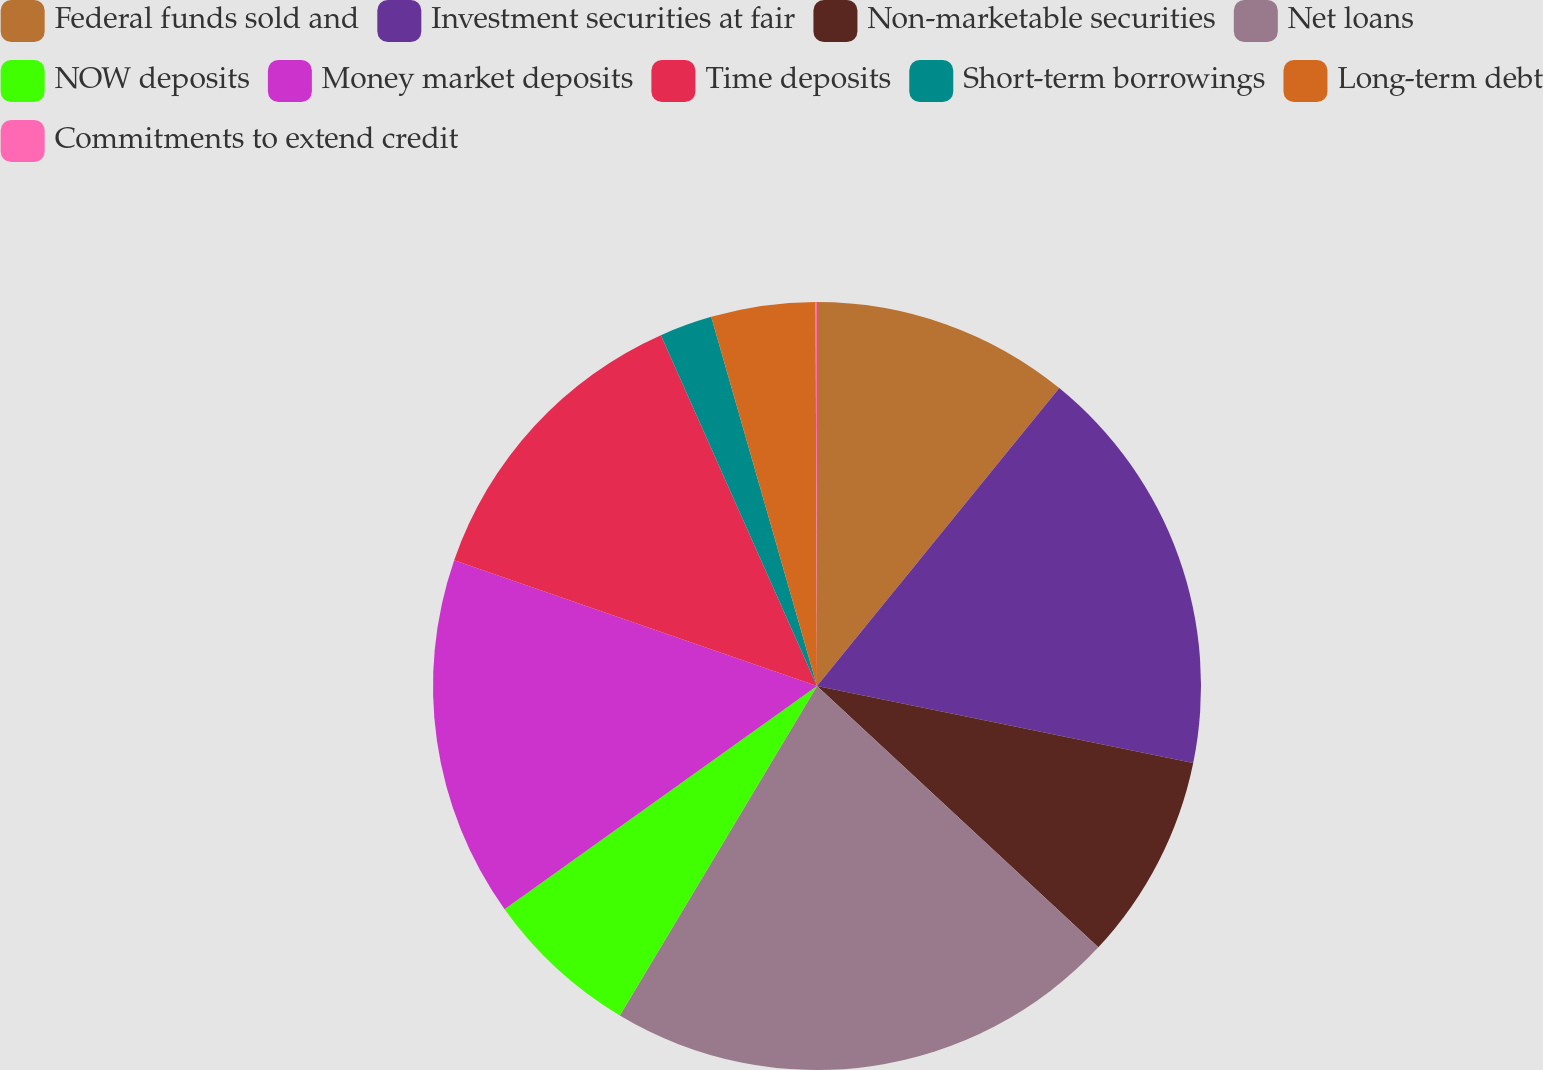<chart> <loc_0><loc_0><loc_500><loc_500><pie_chart><fcel>Federal funds sold and<fcel>Investment securities at fair<fcel>Non-marketable securities<fcel>Net loans<fcel>NOW deposits<fcel>Money market deposits<fcel>Time deposits<fcel>Short-term borrowings<fcel>Long-term debt<fcel>Commitments to extend credit<nl><fcel>10.86%<fcel>17.34%<fcel>8.7%<fcel>21.66%<fcel>6.54%<fcel>15.18%<fcel>13.02%<fcel>2.22%<fcel>4.38%<fcel>0.06%<nl></chart> 